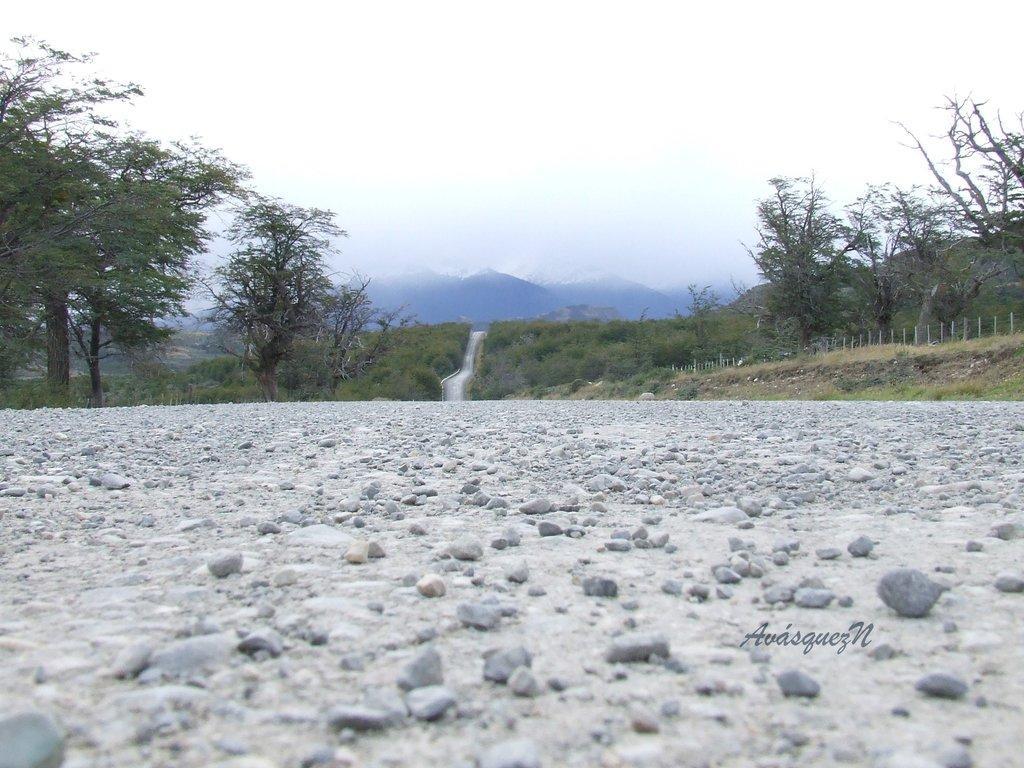How would you summarize this image in a sentence or two? In this image, we can see a waterfall and in the background, there are hills, trees. At the bottom, there is ground covered with stones. 